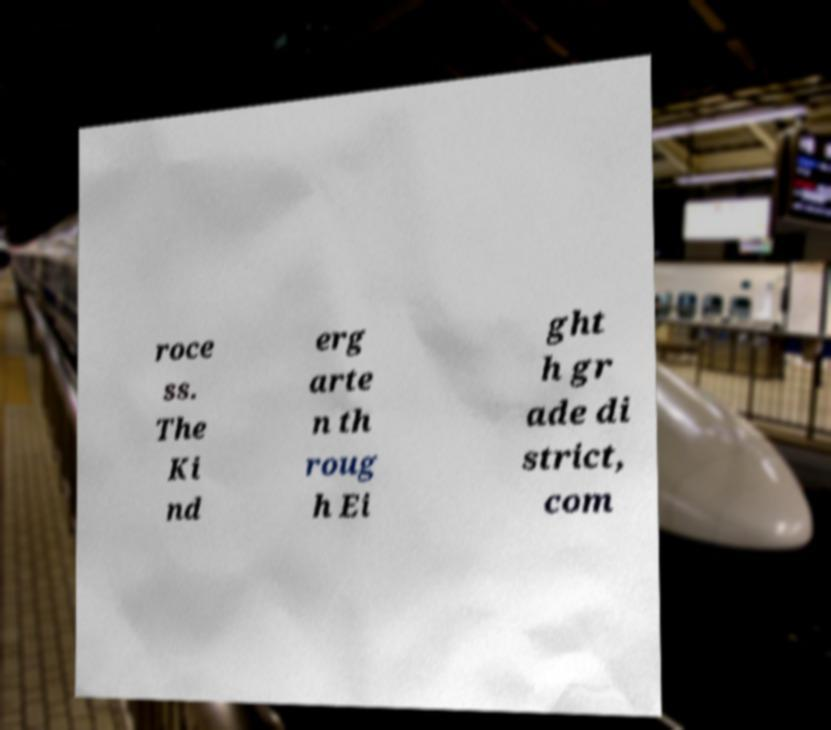Please read and relay the text visible in this image. What does it say? roce ss. The Ki nd erg arte n th roug h Ei ght h gr ade di strict, com 